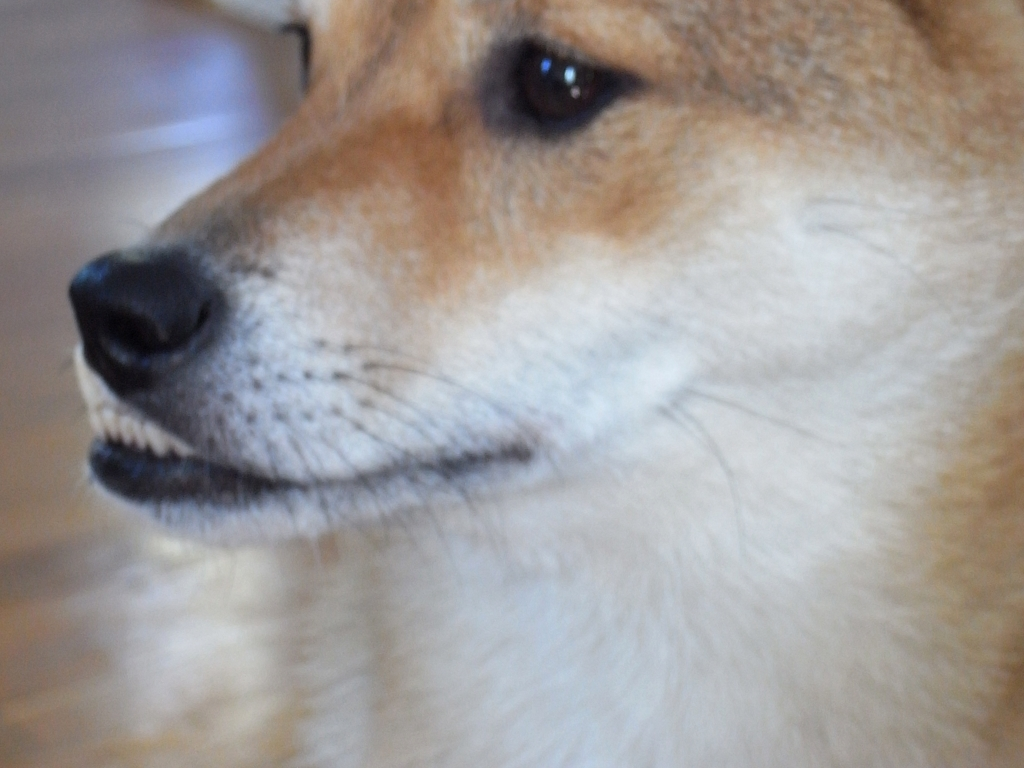What is the lighting condition of the image?
A. bright lighting
B. average lighting
C. excellent lighting
Answer with the option's letter from the given choices directly. The lighting condition in the image can be characterized as B. average lighting. The lighting is sufficient to clearly identify the subject, which is a close-up of a dog, and there's a mellow softness to the light that doesn't produce harsh shadows or overexposed highlights, suggesting that it is neither too bright nor dim. 